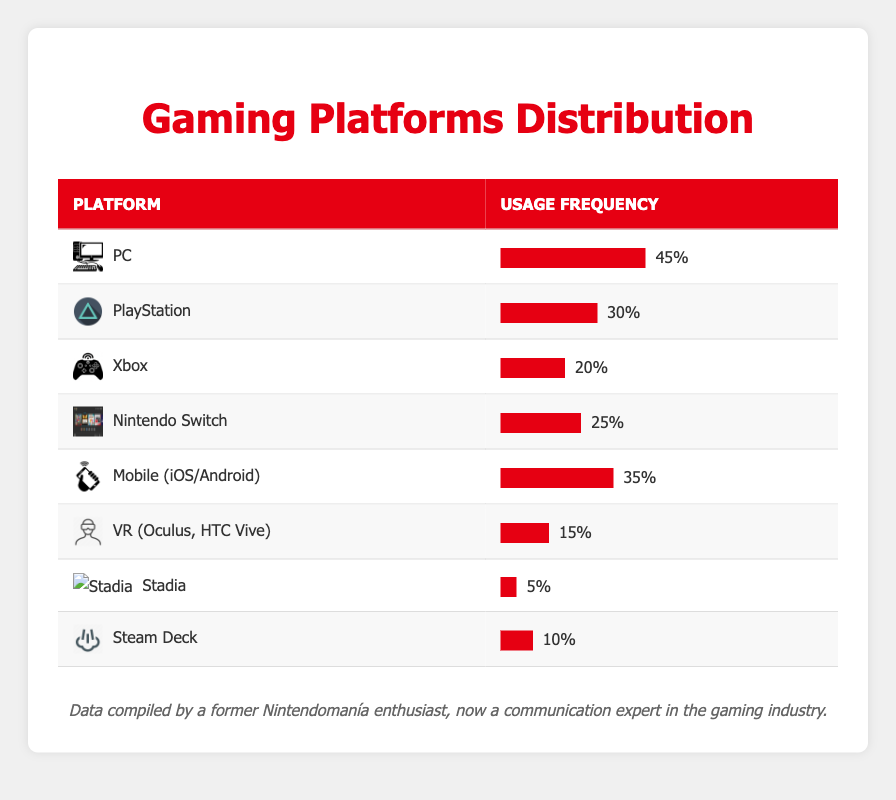What is the usage frequency of the PC platform? The table indicates that the usage frequency for the PC platform is listed specifically under the usage frequency column. It shows a usage frequency of 45.
Answer: 45 Which platform has the lowest usage frequency? By examining the usage frequency of all platforms in the table, I notice that Stadia has the lowest frequency listed at 5.
Answer: Stadia How many platforms have a usage frequency of 30% or more? I can scan through the usage frequency column and count the platforms with 30% or higher. The platforms meeting this criterion are PC (45), PlayStation (30), Mobile (35), and Nintendo Switch (25). In total, there are 4 platforms that have 30% or more usage frequency.
Answer: 4 What is the average usage frequency of all platforms? To find the average usage frequency, I sum up all the usage frequency values: 45 + 30 + 20 + 25 + 35 + 15 + 5 + 10 = 185. Then, since there are 8 platforms, I divide the total by 8: 185 / 8 = 23.125.
Answer: 23.125 Is the usage frequency of VR higher than that of Steam Deck? In the table, the usage frequency of VR is listed as 15, while Steam Deck has 10. Since 15 is greater than 10, the statement is true.
Answer: Yes Which platforms have a combined usage frequency of over 50%? I can check the usage frequencies of various combinations of platforms. Initially checking combinations such as PC (45) and Mobile (35), their combined total is 80, which exceeds 50. Also, PC (45) combined with PlayStation (30) equals 75, which also exceeds 50. Therefore, PC with both Mobile and PlayStation has combined frequencies over 50%.
Answer: PC and Mobile; PC and PlayStation What percentage of communication experts use Xbox? The table states that the usage frequency for Xbox is 20. To express this as a percentage, I note it as 20%.
Answer: 20% How many more communication experts use PC compared to Stadia? Looking at the values, PC has a usage frequency of 45 while Stadia has 5. The difference is calculated as 45 - 5 = 40, indicating that 40 more experts use PC than Stadia.
Answer: 40 What is the total usage frequency of the platforms that are considered "handheld" (Nintendo Switch and Steam Deck)? I find the usage frequencies of both Nintendo Switch, which stands at 25, and Steam Deck at 10. By adding them together (25 + 10), the total usage frequency for these handheld platforms is 35.
Answer: 35 